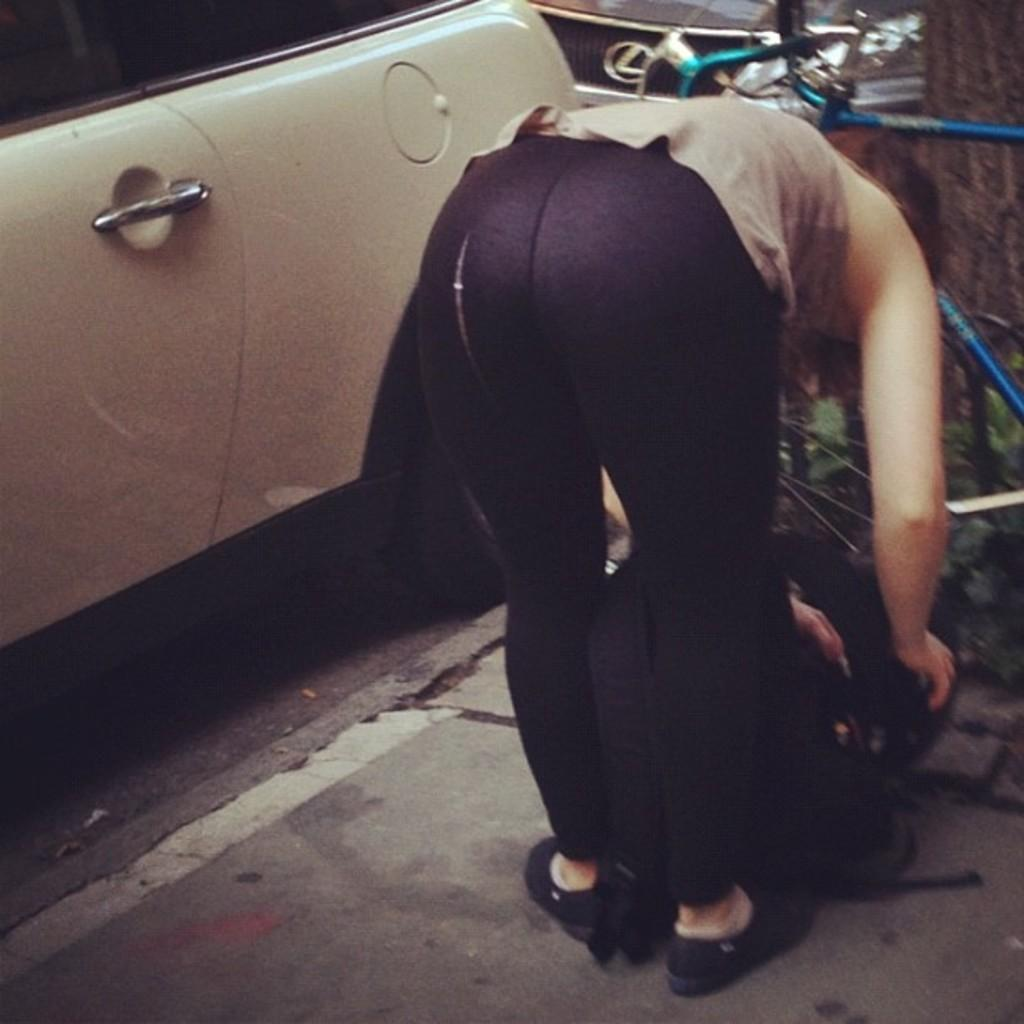Who is the main subject in the image? There is a lady in the center of the image. What is the lady doing in the image? The lady is bending in the image. What is the lady holding in the image? The lady is holding a bag in the image. What can be seen in the background of the image? There are vehicles and plants in the background of the image. What is at the bottom of the image? There is a road at the bottom of the image. What type of stem can be seen growing from the lady's head in the image? There is no stem growing from the lady's head in the image. Is the lady under attack in the image? There is no indication of an attack in the image; the lady is simply bending and holding a bag. 